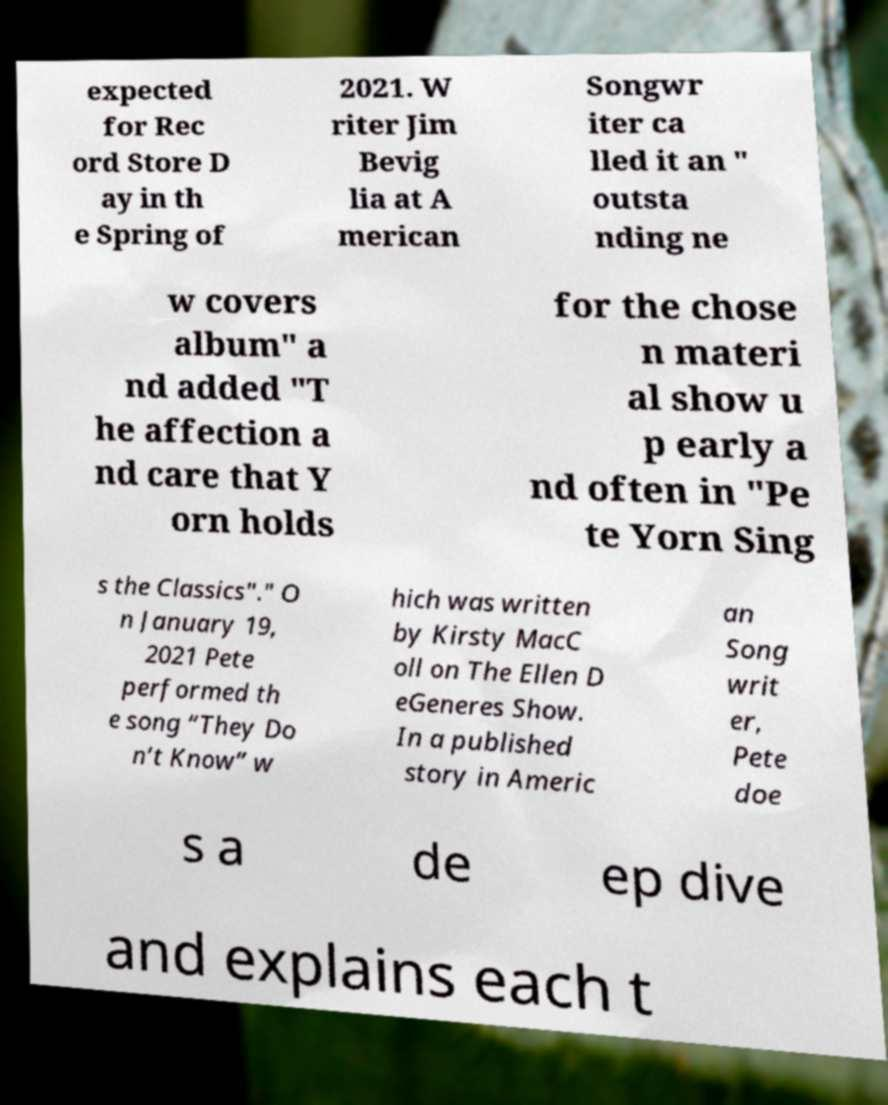Please identify and transcribe the text found in this image. expected for Rec ord Store D ay in th e Spring of 2021. W riter Jim Bevig lia at A merican Songwr iter ca lled it an " outsta nding ne w covers album" a nd added "T he affection a nd care that Y orn holds for the chose n materi al show u p early a nd often in "Pe te Yorn Sing s the Classics"." O n January 19, 2021 Pete performed th e song “They Do n’t Know” w hich was written by Kirsty MacC oll on The Ellen D eGeneres Show. In a published story in Americ an Song writ er, Pete doe s a de ep dive and explains each t 